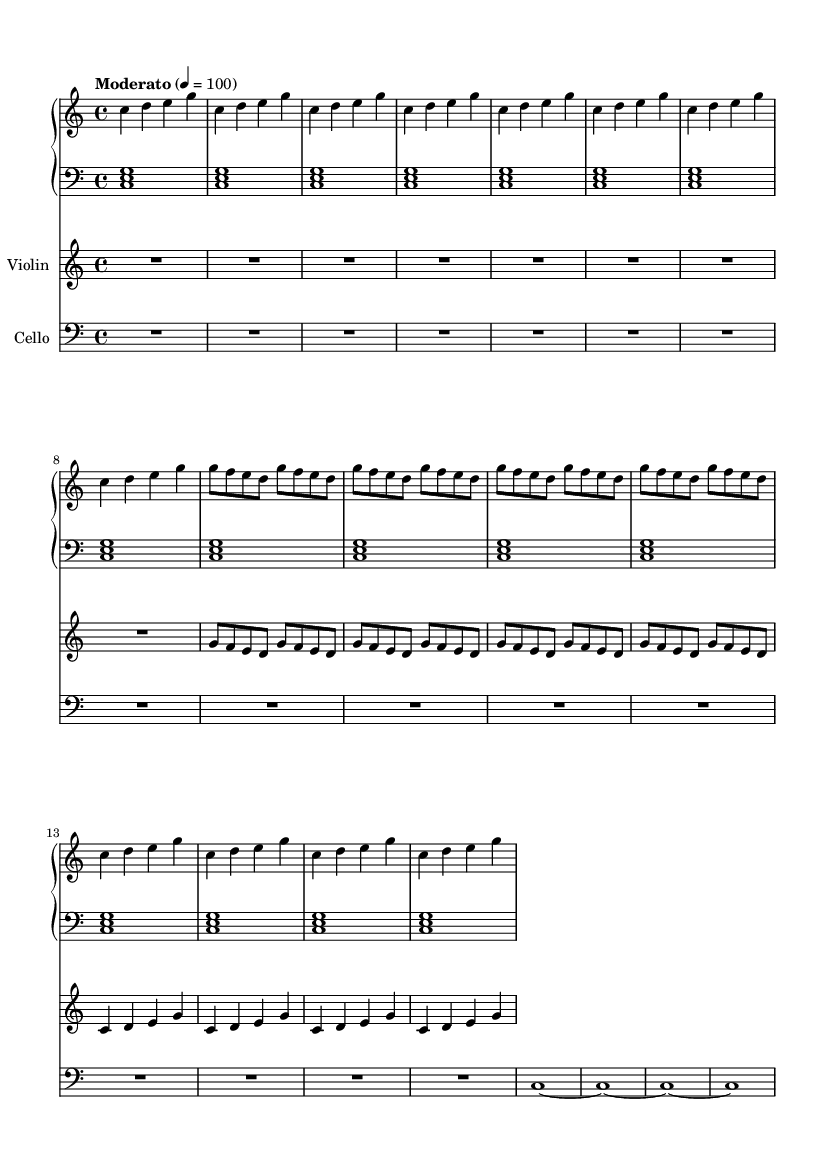What is the key signature of this music? The key signature is indicated at the beginning of the score as C major, which contains no sharps or flats.
Answer: C major What is the time signature of this composition? The time signature appears at the start of the score, indicating that there are four beats per measure, commonly represented as 4/4.
Answer: 4/4 What is the tempo marking of the piece? The tempo marking "Moderato" is specified, which typically suggests a moderate pace, and the number 100 indicates the beats per minute.
Answer: Moderato How many measures are in the piano right hand section? The piano right hand section has a total of 16 measures, as indicated by the repeated motifs and the way they are grouped.
Answer: 16 What is the relationship between the piano left hand and cello parts? Both the piano left hand and cello parts consist of sustained notes and emphasize harmonic support, and they are rhythmically aligned, providing a foundation for the harmonic structure of the piece.
Answer: Harmonic support How many times is the motif "g f e d" repeated in the violin part? The motif "g f e d" is clearly repeated four times in the violin part, as indicated by the repeated notation in the score.
Answer: 4 What type of harmony is primarily used in the piano left hand? The piano left hand primarily employs block chords, creating a solid harmonic base, which is characteristic of minimalist compositions.
Answer: Block chords 